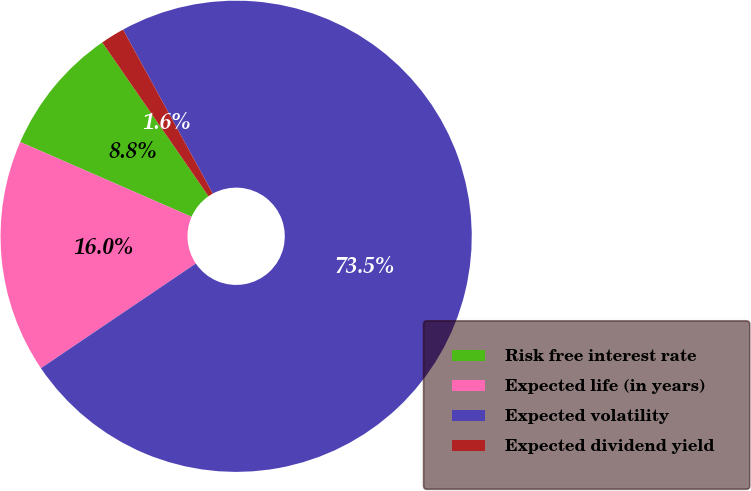<chart> <loc_0><loc_0><loc_500><loc_500><pie_chart><fcel>Risk free interest rate<fcel>Expected life (in years)<fcel>Expected volatility<fcel>Expected dividend yield<nl><fcel>8.83%<fcel>16.01%<fcel>73.51%<fcel>1.65%<nl></chart> 